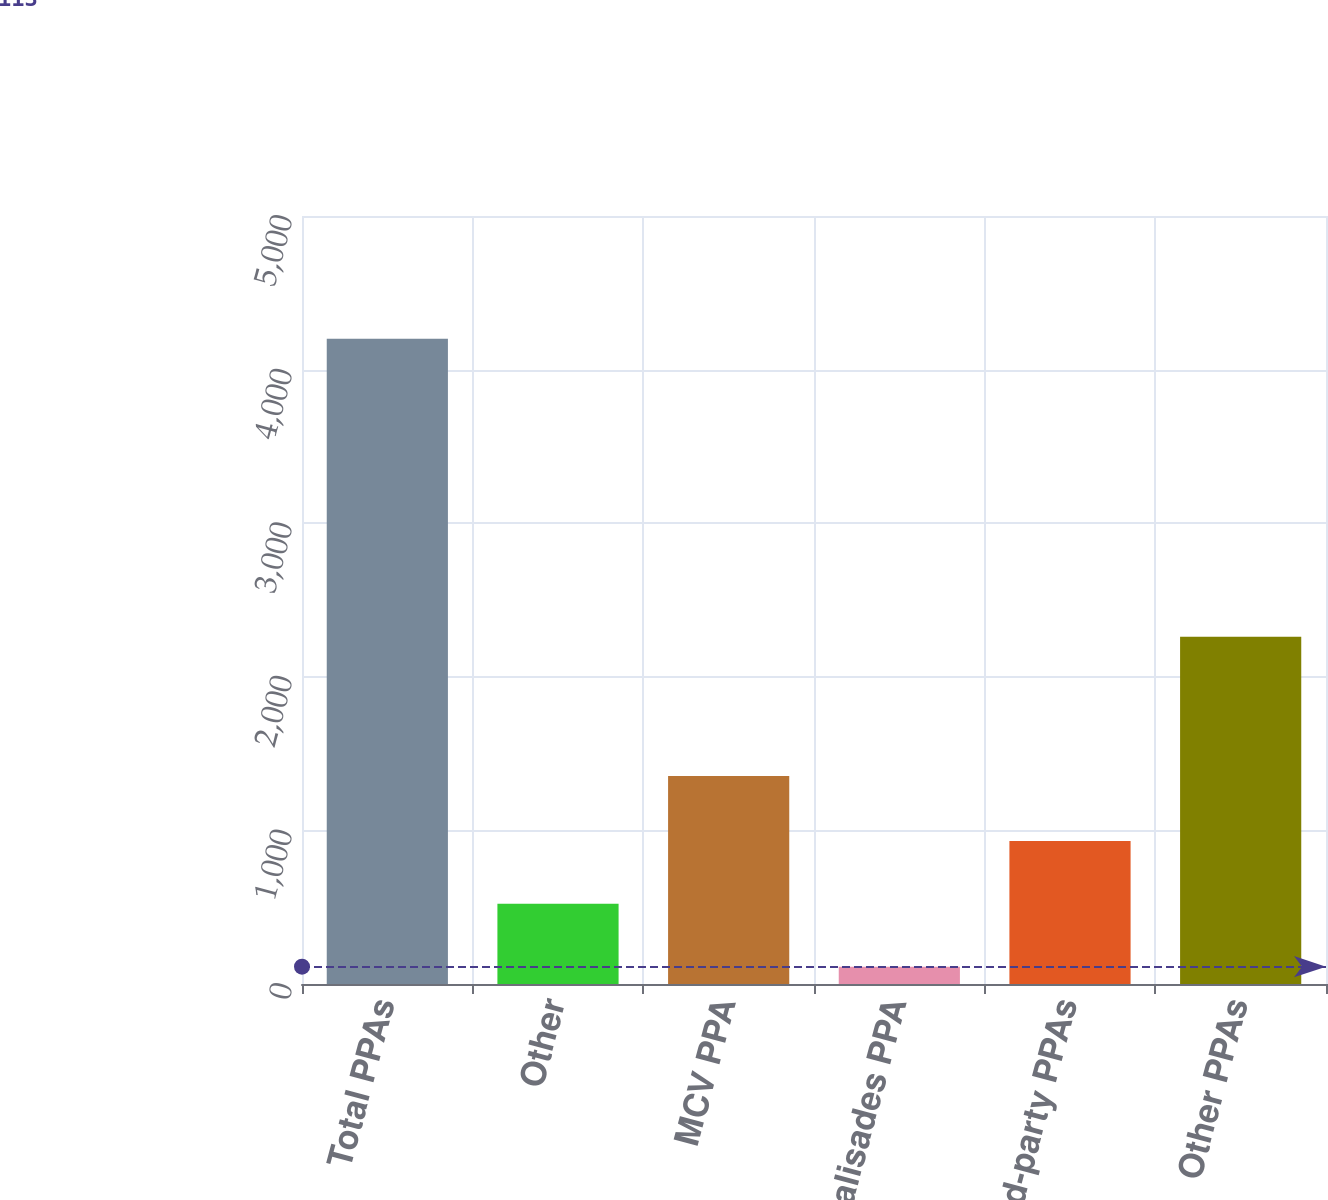<chart> <loc_0><loc_0><loc_500><loc_500><bar_chart><fcel>Total PPAs<fcel>Other<fcel>MCV PPA<fcel>Palisades PPA<fcel>Related-party PPAs<fcel>Other PPAs<nl><fcel>4201<fcel>521.8<fcel>1354<fcel>113<fcel>930.6<fcel>2260<nl></chart> 